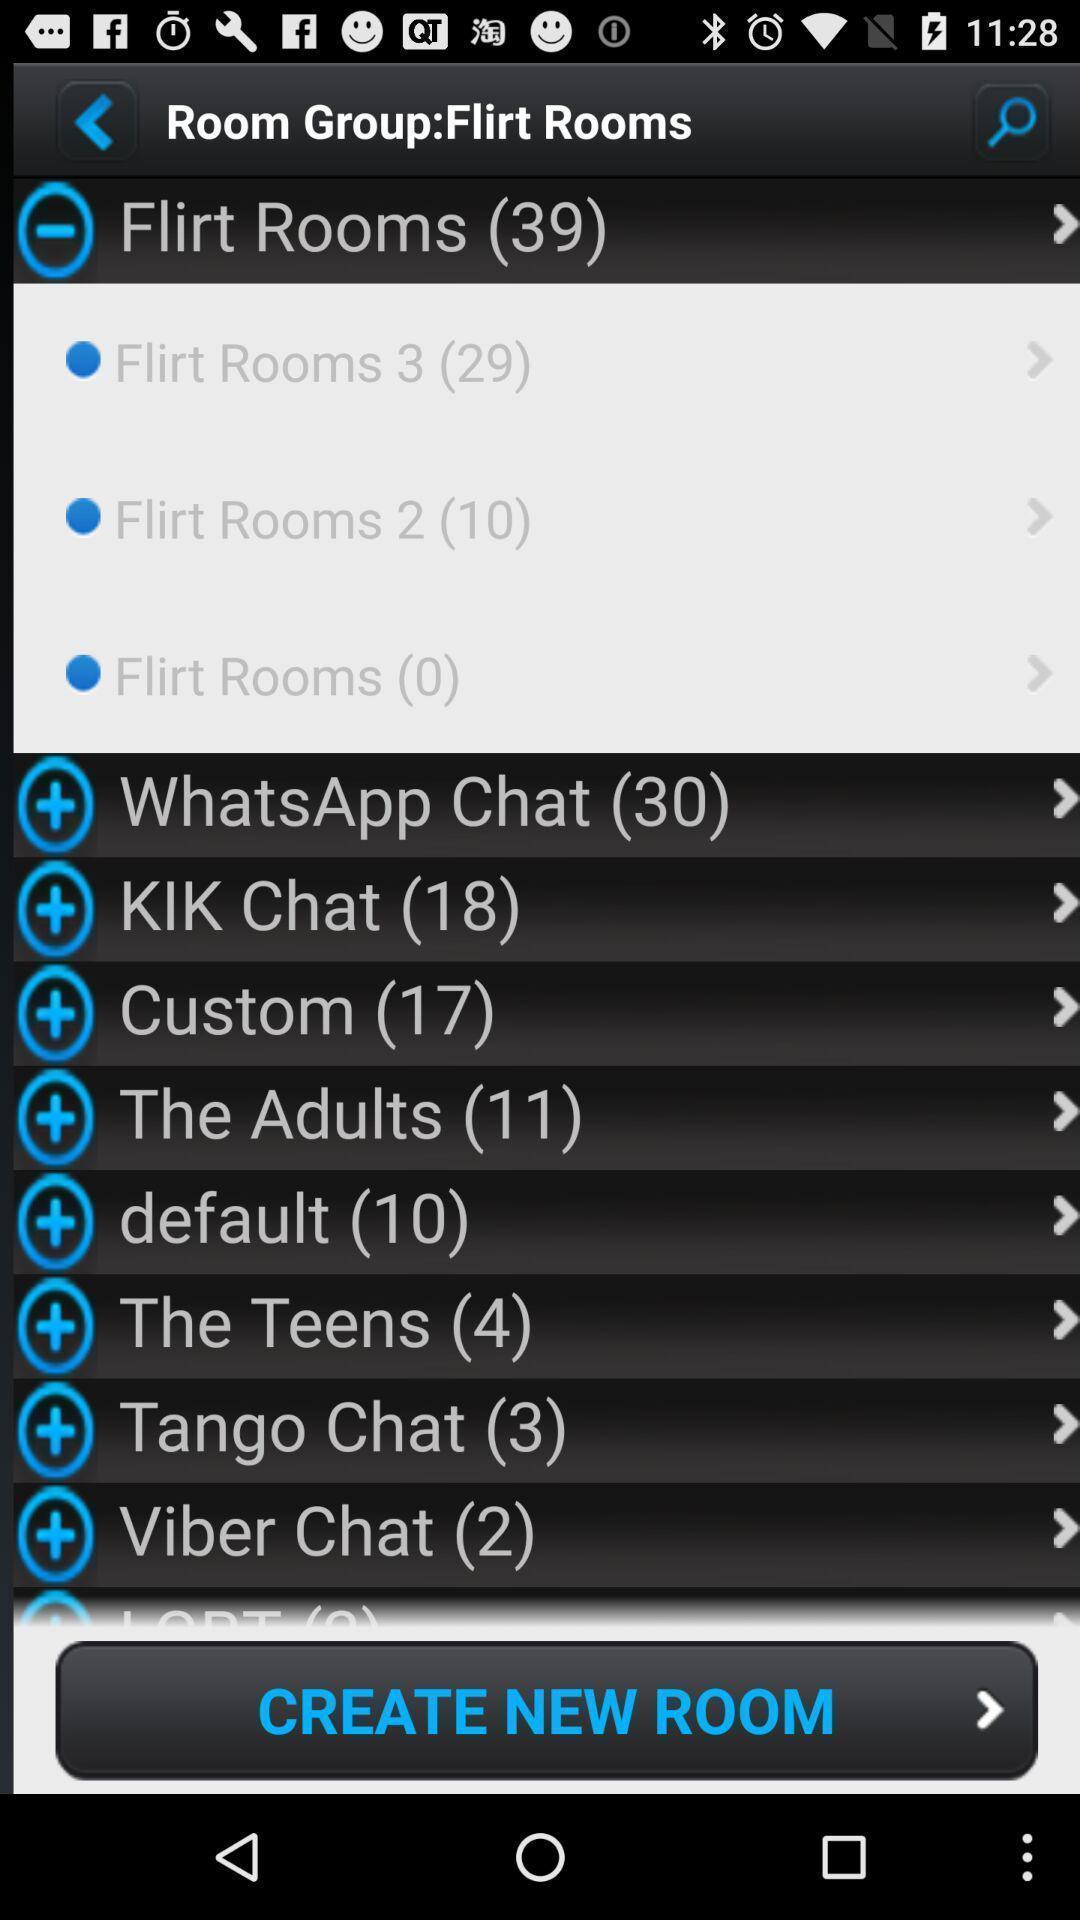Provide a textual representation of this image. Screen shows different room groups. 